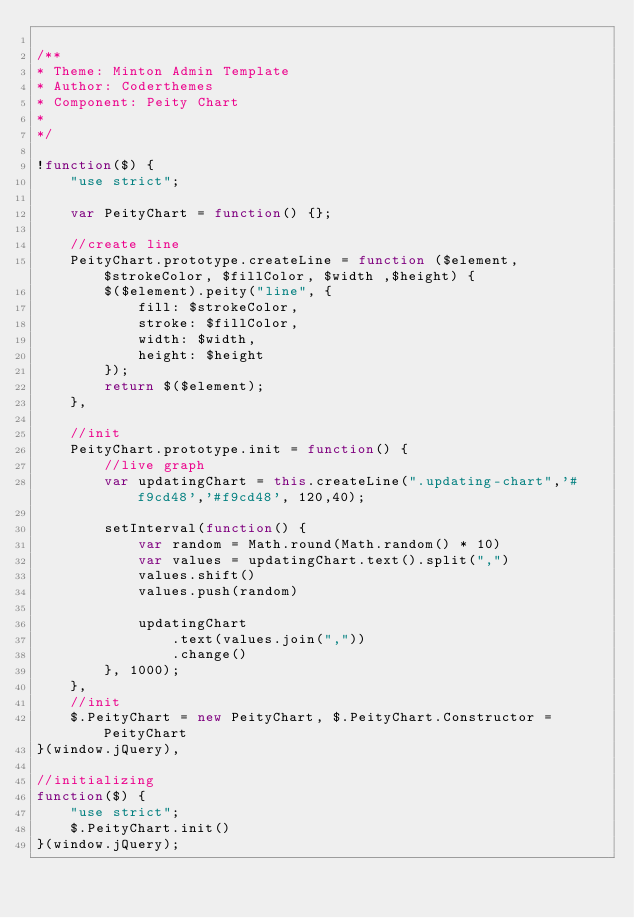Convert code to text. <code><loc_0><loc_0><loc_500><loc_500><_JavaScript_>
/**
* Theme: Minton Admin Template
* Author: Coderthemes
* Component: Peity Chart
* 
*/

!function($) {
    "use strict";

    var PeityChart = function() {};

    //create line
    PeityChart.prototype.createLine = function ($element, $strokeColor, $fillColor, $width ,$height) {
        $($element).peity("line", {
            fill: $strokeColor,
            stroke: $fillColor,
            width: $width,
            height: $height
        });
        return $($element);
    },

    //init
    PeityChart.prototype.init = function() {
        //live graph
        var updatingChart = this.createLine(".updating-chart",'#f9cd48','#f9cd48', 120,40);

        setInterval(function() {
            var random = Math.round(Math.random() * 10)
            var values = updatingChart.text().split(",")
            values.shift()
            values.push(random)

            updatingChart
                .text(values.join(","))
                .change()
        }, 1000);
    },
    //init
    $.PeityChart = new PeityChart, $.PeityChart.Constructor = PeityChart
}(window.jQuery),

//initializing 
function($) {
    "use strict";
    $.PeityChart.init()
}(window.jQuery);
</code> 